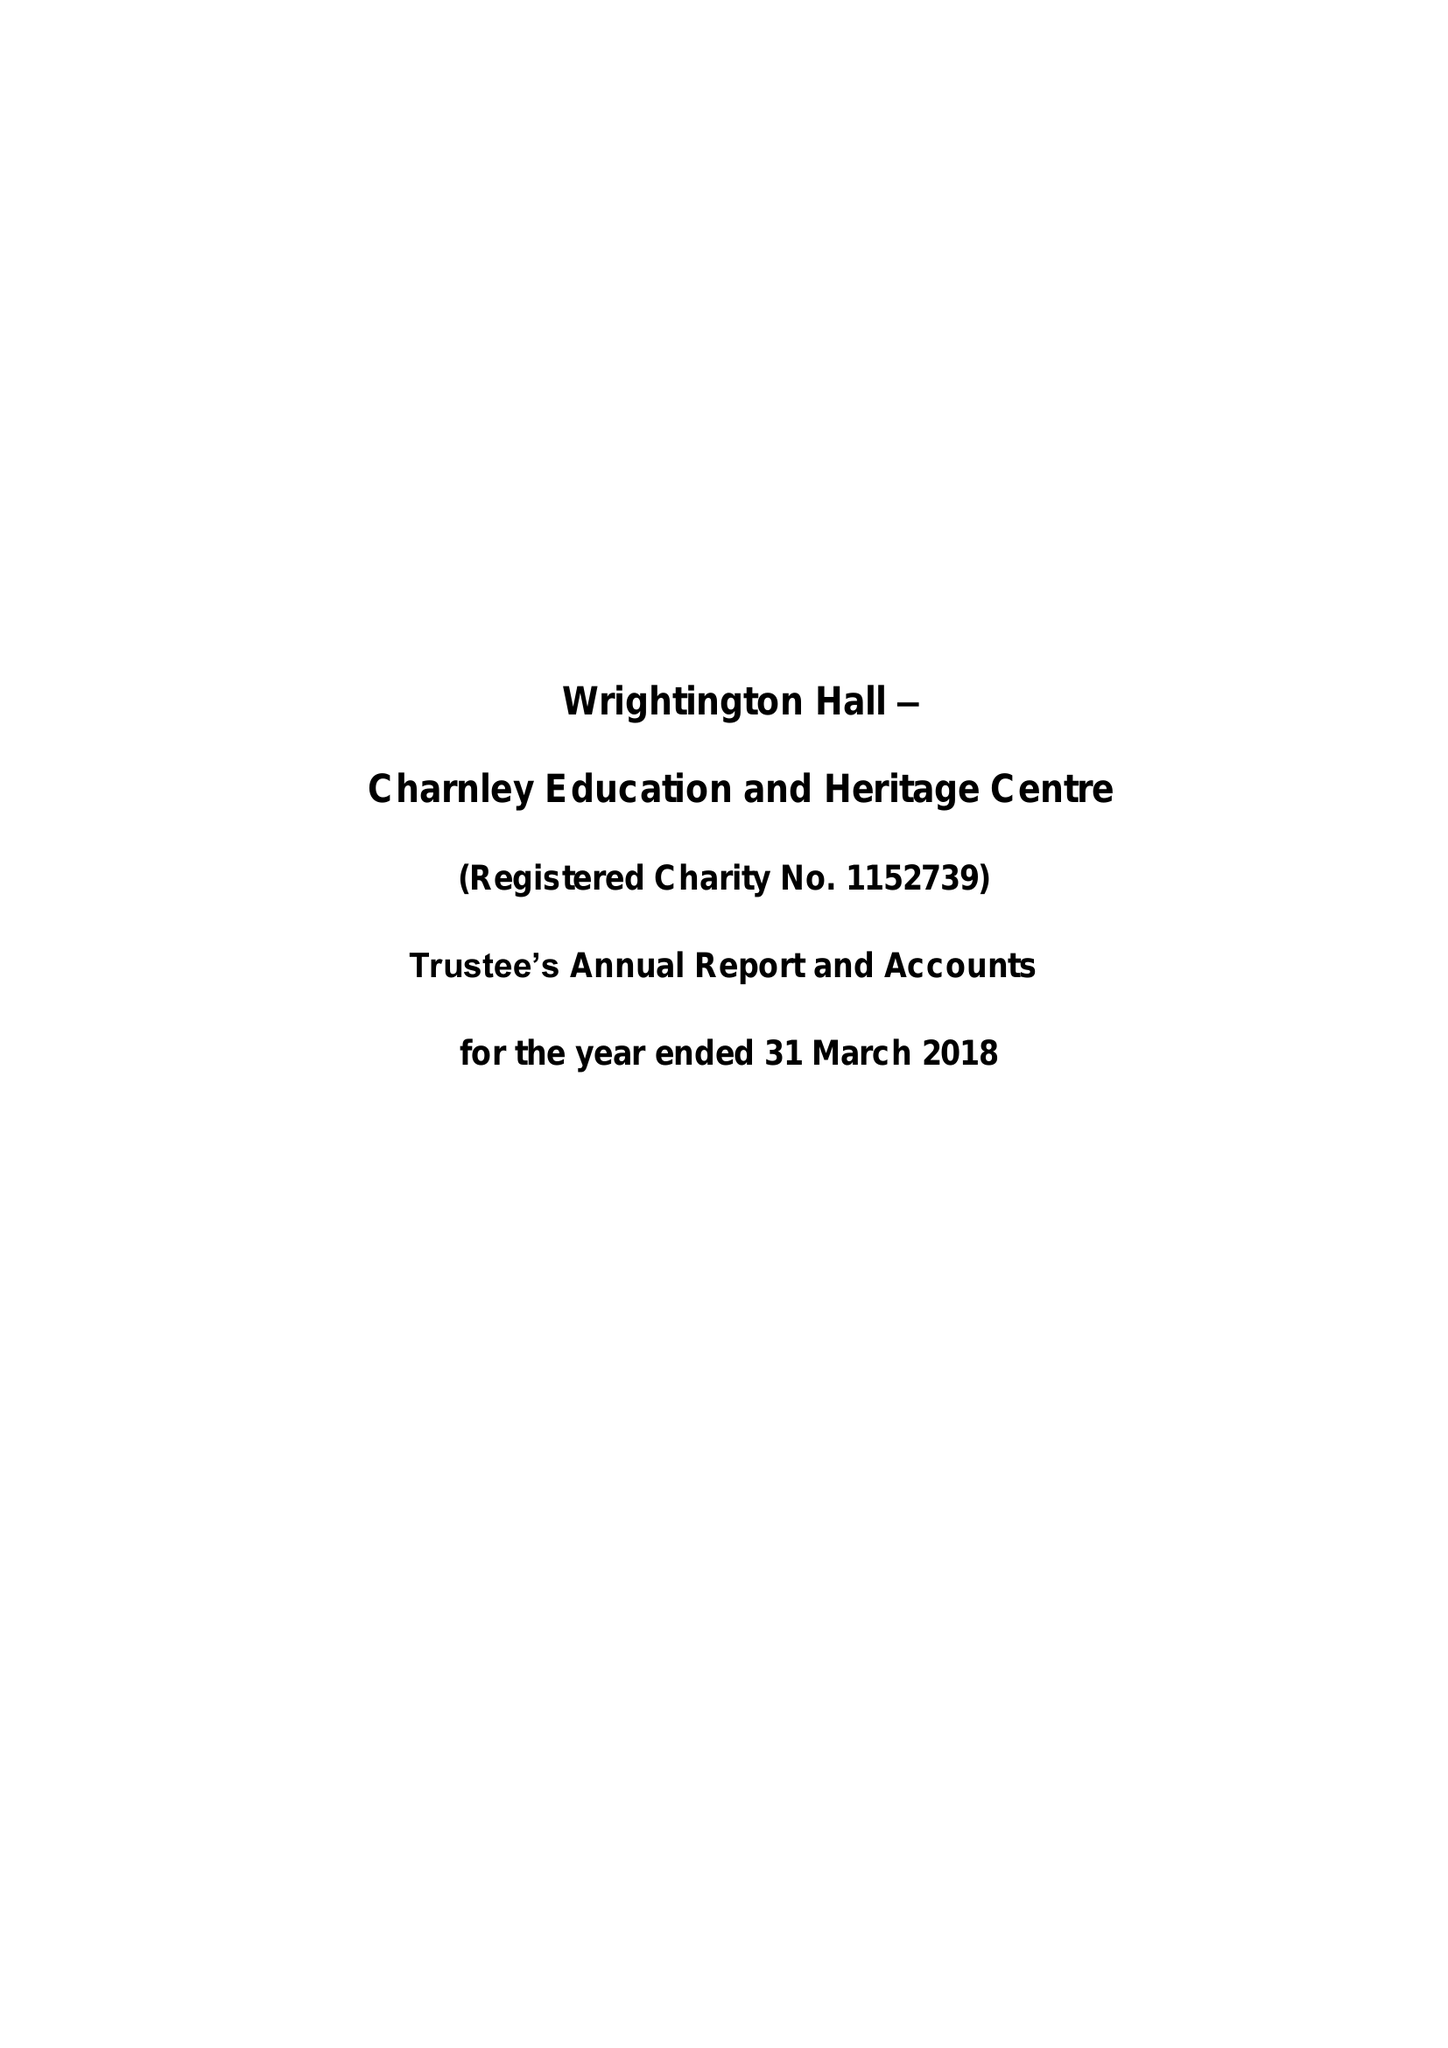What is the value for the address__street_line?
Answer the question using a single word or phrase. 28 EATON AVENUE 